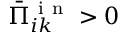Convert formula to latex. <formula><loc_0><loc_0><loc_500><loc_500>\bar { \Pi } _ { i k } ^ { i n } > 0</formula> 